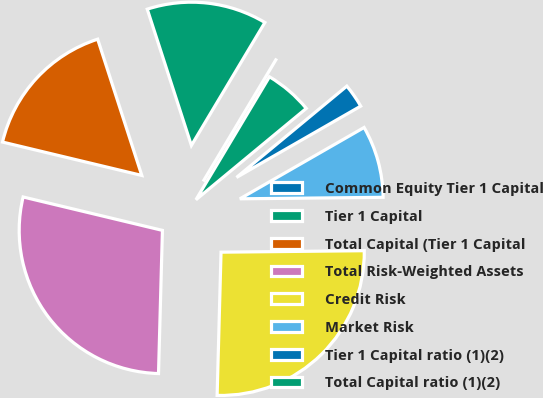<chart> <loc_0><loc_0><loc_500><loc_500><pie_chart><fcel>Common Equity Tier 1 Capital<fcel>Tier 1 Capital<fcel>Total Capital (Tier 1 Capital<fcel>Total Risk-Weighted Assets<fcel>Credit Risk<fcel>Market Risk<fcel>Tier 1 Capital ratio (1)(2)<fcel>Total Capital ratio (1)(2)<nl><fcel>0.0%<fcel>13.56%<fcel>16.27%<fcel>28.31%<fcel>25.6%<fcel>8.13%<fcel>2.71%<fcel>5.42%<nl></chart> 